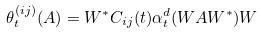Convert formula to latex. <formula><loc_0><loc_0><loc_500><loc_500>\theta _ { t } ^ { ( i j ) } ( A ) = W ^ { * } C _ { i j } ( t ) \alpha ^ { d } _ { t } ( W A W ^ { * } ) W</formula> 